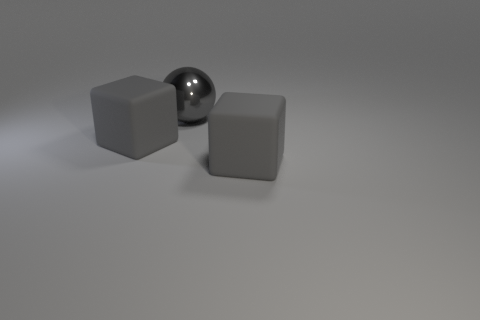Is there anything else that has the same shape as the large gray metal object?
Provide a succinct answer. No. There is a gray rubber thing that is on the left side of the cube in front of the gray rubber thing on the left side of the large gray shiny sphere; what is its size?
Provide a short and direct response. Large. What number of other things are the same color as the shiny sphere?
Your answer should be compact. 2. There is a block on the right side of the ball; what is its size?
Offer a very short reply. Large. Do the cube that is on the left side of the gray metal object and the large matte object right of the shiny ball have the same color?
Your response must be concise. Yes. There is a gray block that is on the left side of the big gray thing behind the large matte block to the left of the gray metallic object; what is it made of?
Keep it short and to the point. Rubber. Are there any rubber things that have the same size as the ball?
Give a very brief answer. Yes. Is the gray object on the left side of the big sphere made of the same material as the thing that is right of the big gray ball?
Make the answer very short. Yes. How many gray matte things have the same shape as the metallic object?
Make the answer very short. 0. How many things are blue rubber objects or big gray objects in front of the large gray ball?
Your response must be concise. 2. 